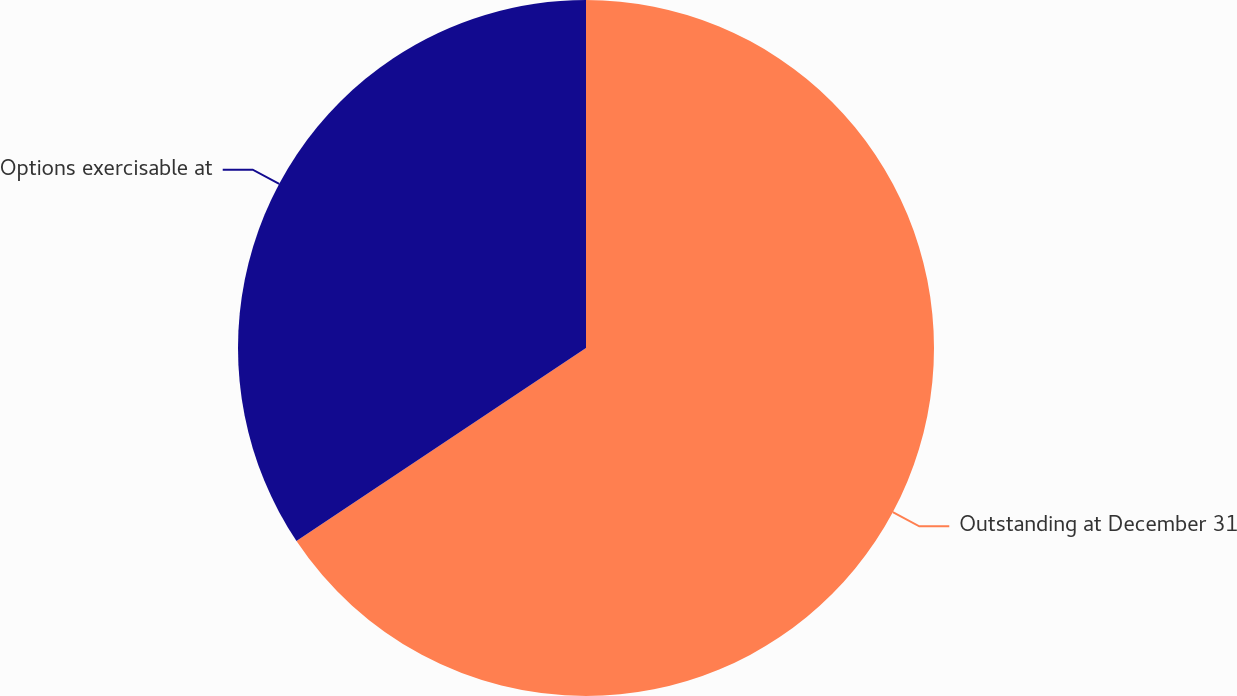Convert chart. <chart><loc_0><loc_0><loc_500><loc_500><pie_chart><fcel>Outstanding at December 31<fcel>Options exercisable at<nl><fcel>65.64%<fcel>34.36%<nl></chart> 